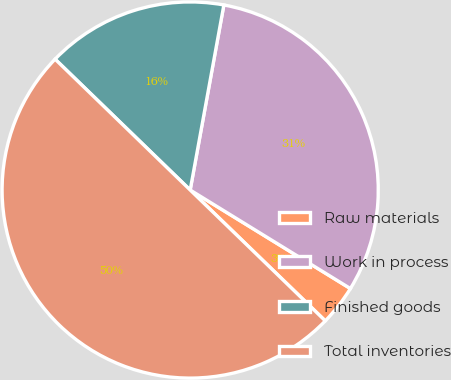Convert chart to OTSL. <chart><loc_0><loc_0><loc_500><loc_500><pie_chart><fcel>Raw materials<fcel>Work in process<fcel>Finished goods<fcel>Total inventories<nl><fcel>3.47%<fcel>30.91%<fcel>15.62%<fcel>50.0%<nl></chart> 